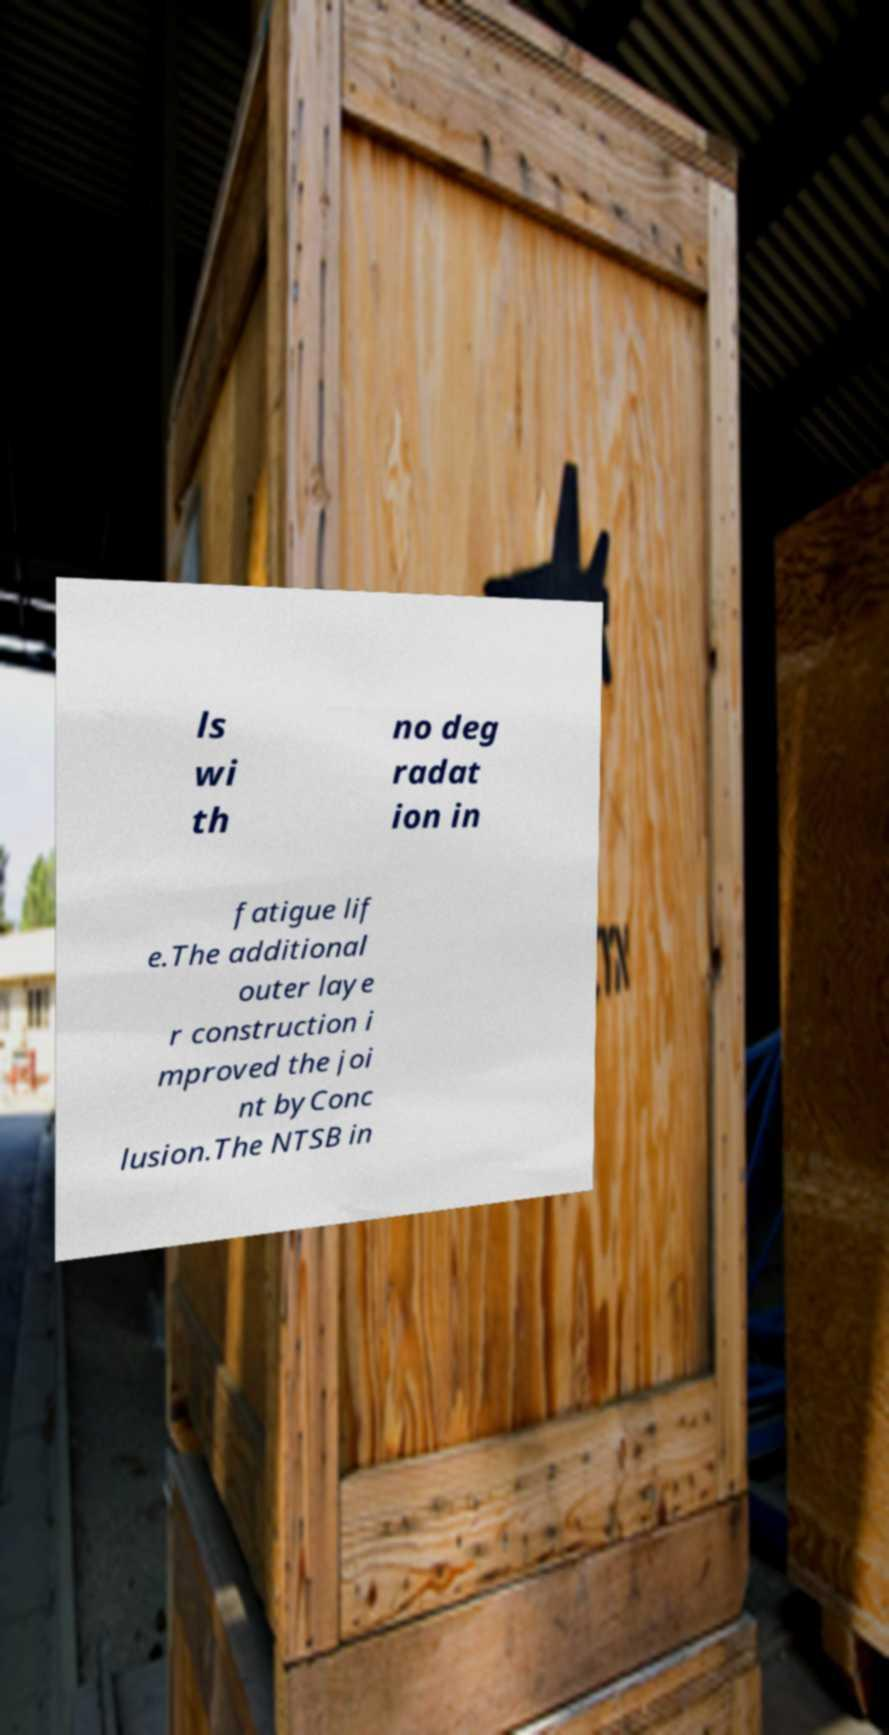I need the written content from this picture converted into text. Can you do that? ls wi th no deg radat ion in fatigue lif e.The additional outer laye r construction i mproved the joi nt byConc lusion.The NTSB in 